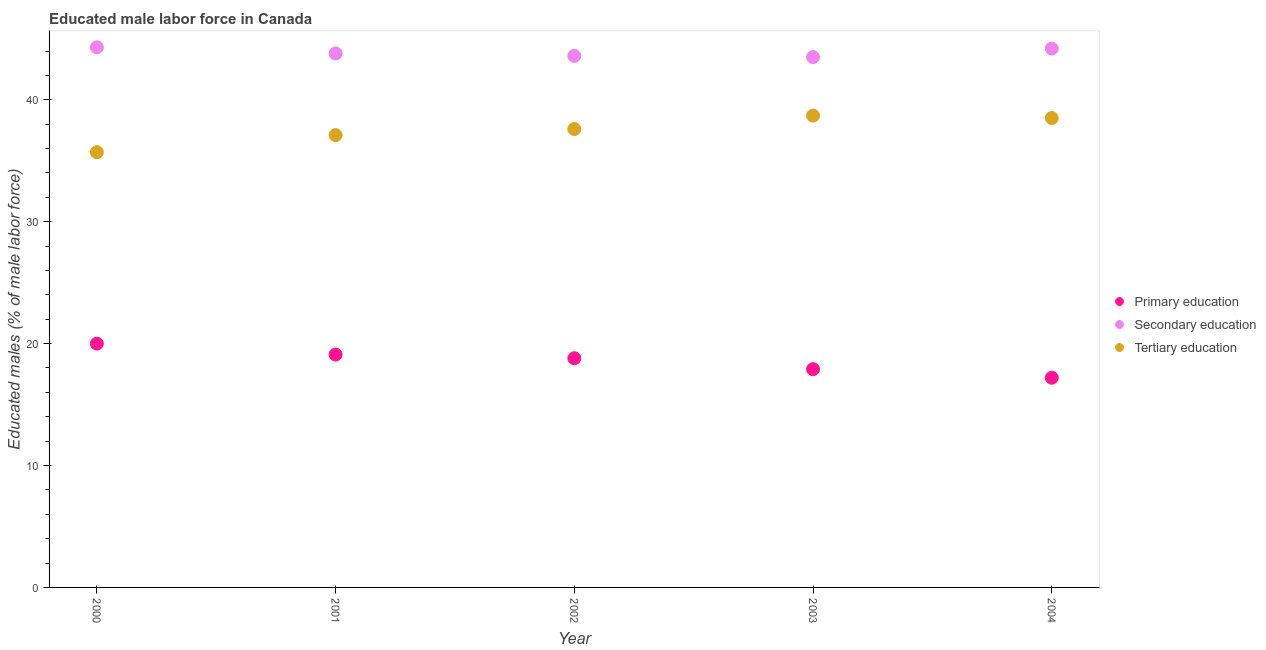How many different coloured dotlines are there?
Make the answer very short. 3. Is the number of dotlines equal to the number of legend labels?
Offer a very short reply. Yes. Across all years, what is the maximum percentage of male labor force who received tertiary education?
Offer a terse response. 38.7. Across all years, what is the minimum percentage of male labor force who received tertiary education?
Give a very brief answer. 35.7. In which year was the percentage of male labor force who received secondary education maximum?
Your answer should be compact. 2000. In which year was the percentage of male labor force who received tertiary education minimum?
Your response must be concise. 2000. What is the total percentage of male labor force who received tertiary education in the graph?
Make the answer very short. 187.6. What is the difference between the percentage of male labor force who received secondary education in 2001 and that in 2003?
Keep it short and to the point. 0.3. What is the difference between the percentage of male labor force who received secondary education in 2001 and the percentage of male labor force who received primary education in 2002?
Give a very brief answer. 25. What is the average percentage of male labor force who received primary education per year?
Offer a terse response. 18.6. In the year 2004, what is the difference between the percentage of male labor force who received tertiary education and percentage of male labor force who received secondary education?
Provide a succinct answer. -5.7. What is the ratio of the percentage of male labor force who received primary education in 2002 to that in 2004?
Offer a very short reply. 1.09. Is the percentage of male labor force who received secondary education in 2001 less than that in 2002?
Keep it short and to the point. No. Is the difference between the percentage of male labor force who received tertiary education in 2003 and 2004 greater than the difference between the percentage of male labor force who received primary education in 2003 and 2004?
Offer a very short reply. No. What is the difference between the highest and the second highest percentage of male labor force who received tertiary education?
Your answer should be compact. 0.2. What is the difference between the highest and the lowest percentage of male labor force who received secondary education?
Keep it short and to the point. 0.8. How many years are there in the graph?
Offer a terse response. 5. What is the difference between two consecutive major ticks on the Y-axis?
Ensure brevity in your answer.  10. Are the values on the major ticks of Y-axis written in scientific E-notation?
Your answer should be compact. No. How many legend labels are there?
Provide a short and direct response. 3. How are the legend labels stacked?
Your answer should be very brief. Vertical. What is the title of the graph?
Offer a terse response. Educated male labor force in Canada. What is the label or title of the X-axis?
Your response must be concise. Year. What is the label or title of the Y-axis?
Provide a short and direct response. Educated males (% of male labor force). What is the Educated males (% of male labor force) in Primary education in 2000?
Ensure brevity in your answer.  20. What is the Educated males (% of male labor force) in Secondary education in 2000?
Provide a short and direct response. 44.3. What is the Educated males (% of male labor force) of Tertiary education in 2000?
Offer a very short reply. 35.7. What is the Educated males (% of male labor force) in Primary education in 2001?
Your answer should be compact. 19.1. What is the Educated males (% of male labor force) in Secondary education in 2001?
Provide a short and direct response. 43.8. What is the Educated males (% of male labor force) of Tertiary education in 2001?
Provide a short and direct response. 37.1. What is the Educated males (% of male labor force) of Primary education in 2002?
Offer a very short reply. 18.8. What is the Educated males (% of male labor force) of Secondary education in 2002?
Give a very brief answer. 43.6. What is the Educated males (% of male labor force) in Tertiary education in 2002?
Your response must be concise. 37.6. What is the Educated males (% of male labor force) of Primary education in 2003?
Offer a terse response. 17.9. What is the Educated males (% of male labor force) of Secondary education in 2003?
Make the answer very short. 43.5. What is the Educated males (% of male labor force) of Tertiary education in 2003?
Make the answer very short. 38.7. What is the Educated males (% of male labor force) in Primary education in 2004?
Offer a very short reply. 17.2. What is the Educated males (% of male labor force) in Secondary education in 2004?
Provide a succinct answer. 44.2. What is the Educated males (% of male labor force) in Tertiary education in 2004?
Provide a succinct answer. 38.5. Across all years, what is the maximum Educated males (% of male labor force) of Secondary education?
Keep it short and to the point. 44.3. Across all years, what is the maximum Educated males (% of male labor force) of Tertiary education?
Your answer should be compact. 38.7. Across all years, what is the minimum Educated males (% of male labor force) of Primary education?
Offer a very short reply. 17.2. Across all years, what is the minimum Educated males (% of male labor force) in Secondary education?
Your answer should be compact. 43.5. Across all years, what is the minimum Educated males (% of male labor force) in Tertiary education?
Offer a terse response. 35.7. What is the total Educated males (% of male labor force) in Primary education in the graph?
Your answer should be compact. 93. What is the total Educated males (% of male labor force) in Secondary education in the graph?
Provide a short and direct response. 219.4. What is the total Educated males (% of male labor force) of Tertiary education in the graph?
Provide a short and direct response. 187.6. What is the difference between the Educated males (% of male labor force) of Primary education in 2000 and that in 2001?
Make the answer very short. 0.9. What is the difference between the Educated males (% of male labor force) of Secondary education in 2000 and that in 2001?
Provide a succinct answer. 0.5. What is the difference between the Educated males (% of male labor force) of Secondary education in 2000 and that in 2002?
Your response must be concise. 0.7. What is the difference between the Educated males (% of male labor force) of Tertiary education in 2000 and that in 2003?
Make the answer very short. -3. What is the difference between the Educated males (% of male labor force) in Secondary education in 2000 and that in 2004?
Offer a very short reply. 0.1. What is the difference between the Educated males (% of male labor force) in Primary education in 2001 and that in 2002?
Offer a very short reply. 0.3. What is the difference between the Educated males (% of male labor force) of Tertiary education in 2001 and that in 2002?
Ensure brevity in your answer.  -0.5. What is the difference between the Educated males (% of male labor force) in Secondary education in 2001 and that in 2003?
Give a very brief answer. 0.3. What is the difference between the Educated males (% of male labor force) in Primary education in 2001 and that in 2004?
Your answer should be compact. 1.9. What is the difference between the Educated males (% of male labor force) of Tertiary education in 2001 and that in 2004?
Give a very brief answer. -1.4. What is the difference between the Educated males (% of male labor force) in Secondary education in 2002 and that in 2003?
Provide a succinct answer. 0.1. What is the difference between the Educated males (% of male labor force) of Primary education in 2002 and that in 2004?
Your response must be concise. 1.6. What is the difference between the Educated males (% of male labor force) in Primary education in 2000 and the Educated males (% of male labor force) in Secondary education in 2001?
Keep it short and to the point. -23.8. What is the difference between the Educated males (% of male labor force) of Primary education in 2000 and the Educated males (% of male labor force) of Tertiary education in 2001?
Your answer should be compact. -17.1. What is the difference between the Educated males (% of male labor force) of Secondary education in 2000 and the Educated males (% of male labor force) of Tertiary education in 2001?
Offer a terse response. 7.2. What is the difference between the Educated males (% of male labor force) in Primary education in 2000 and the Educated males (% of male labor force) in Secondary education in 2002?
Your answer should be compact. -23.6. What is the difference between the Educated males (% of male labor force) in Primary education in 2000 and the Educated males (% of male labor force) in Tertiary education in 2002?
Give a very brief answer. -17.6. What is the difference between the Educated males (% of male labor force) in Secondary education in 2000 and the Educated males (% of male labor force) in Tertiary education in 2002?
Offer a terse response. 6.7. What is the difference between the Educated males (% of male labor force) in Primary education in 2000 and the Educated males (% of male labor force) in Secondary education in 2003?
Give a very brief answer. -23.5. What is the difference between the Educated males (% of male labor force) of Primary education in 2000 and the Educated males (% of male labor force) of Tertiary education in 2003?
Provide a succinct answer. -18.7. What is the difference between the Educated males (% of male labor force) of Secondary education in 2000 and the Educated males (% of male labor force) of Tertiary education in 2003?
Offer a terse response. 5.6. What is the difference between the Educated males (% of male labor force) of Primary education in 2000 and the Educated males (% of male labor force) of Secondary education in 2004?
Ensure brevity in your answer.  -24.2. What is the difference between the Educated males (% of male labor force) in Primary education in 2000 and the Educated males (% of male labor force) in Tertiary education in 2004?
Your answer should be very brief. -18.5. What is the difference between the Educated males (% of male labor force) of Primary education in 2001 and the Educated males (% of male labor force) of Secondary education in 2002?
Keep it short and to the point. -24.5. What is the difference between the Educated males (% of male labor force) of Primary education in 2001 and the Educated males (% of male labor force) of Tertiary education in 2002?
Ensure brevity in your answer.  -18.5. What is the difference between the Educated males (% of male labor force) in Secondary education in 2001 and the Educated males (% of male labor force) in Tertiary education in 2002?
Give a very brief answer. 6.2. What is the difference between the Educated males (% of male labor force) of Primary education in 2001 and the Educated males (% of male labor force) of Secondary education in 2003?
Ensure brevity in your answer.  -24.4. What is the difference between the Educated males (% of male labor force) of Primary education in 2001 and the Educated males (% of male labor force) of Tertiary education in 2003?
Your response must be concise. -19.6. What is the difference between the Educated males (% of male labor force) in Secondary education in 2001 and the Educated males (% of male labor force) in Tertiary education in 2003?
Keep it short and to the point. 5.1. What is the difference between the Educated males (% of male labor force) of Primary education in 2001 and the Educated males (% of male labor force) of Secondary education in 2004?
Your response must be concise. -25.1. What is the difference between the Educated males (% of male labor force) of Primary education in 2001 and the Educated males (% of male labor force) of Tertiary education in 2004?
Give a very brief answer. -19.4. What is the difference between the Educated males (% of male labor force) of Primary education in 2002 and the Educated males (% of male labor force) of Secondary education in 2003?
Keep it short and to the point. -24.7. What is the difference between the Educated males (% of male labor force) of Primary education in 2002 and the Educated males (% of male labor force) of Tertiary education in 2003?
Provide a short and direct response. -19.9. What is the difference between the Educated males (% of male labor force) of Primary education in 2002 and the Educated males (% of male labor force) of Secondary education in 2004?
Ensure brevity in your answer.  -25.4. What is the difference between the Educated males (% of male labor force) in Primary education in 2002 and the Educated males (% of male labor force) in Tertiary education in 2004?
Offer a very short reply. -19.7. What is the difference between the Educated males (% of male labor force) in Secondary education in 2002 and the Educated males (% of male labor force) in Tertiary education in 2004?
Give a very brief answer. 5.1. What is the difference between the Educated males (% of male labor force) in Primary education in 2003 and the Educated males (% of male labor force) in Secondary education in 2004?
Provide a succinct answer. -26.3. What is the difference between the Educated males (% of male labor force) in Primary education in 2003 and the Educated males (% of male labor force) in Tertiary education in 2004?
Offer a terse response. -20.6. What is the difference between the Educated males (% of male labor force) of Secondary education in 2003 and the Educated males (% of male labor force) of Tertiary education in 2004?
Keep it short and to the point. 5. What is the average Educated males (% of male labor force) of Primary education per year?
Provide a short and direct response. 18.6. What is the average Educated males (% of male labor force) of Secondary education per year?
Keep it short and to the point. 43.88. What is the average Educated males (% of male labor force) in Tertiary education per year?
Your answer should be compact. 37.52. In the year 2000, what is the difference between the Educated males (% of male labor force) of Primary education and Educated males (% of male labor force) of Secondary education?
Ensure brevity in your answer.  -24.3. In the year 2000, what is the difference between the Educated males (% of male labor force) in Primary education and Educated males (% of male labor force) in Tertiary education?
Offer a terse response. -15.7. In the year 2000, what is the difference between the Educated males (% of male labor force) in Secondary education and Educated males (% of male labor force) in Tertiary education?
Ensure brevity in your answer.  8.6. In the year 2001, what is the difference between the Educated males (% of male labor force) in Primary education and Educated males (% of male labor force) in Secondary education?
Ensure brevity in your answer.  -24.7. In the year 2001, what is the difference between the Educated males (% of male labor force) in Primary education and Educated males (% of male labor force) in Tertiary education?
Offer a terse response. -18. In the year 2002, what is the difference between the Educated males (% of male labor force) in Primary education and Educated males (% of male labor force) in Secondary education?
Your response must be concise. -24.8. In the year 2002, what is the difference between the Educated males (% of male labor force) of Primary education and Educated males (% of male labor force) of Tertiary education?
Provide a short and direct response. -18.8. In the year 2003, what is the difference between the Educated males (% of male labor force) of Primary education and Educated males (% of male labor force) of Secondary education?
Your answer should be very brief. -25.6. In the year 2003, what is the difference between the Educated males (% of male labor force) of Primary education and Educated males (% of male labor force) of Tertiary education?
Your answer should be very brief. -20.8. In the year 2004, what is the difference between the Educated males (% of male labor force) of Primary education and Educated males (% of male labor force) of Tertiary education?
Offer a terse response. -21.3. In the year 2004, what is the difference between the Educated males (% of male labor force) in Secondary education and Educated males (% of male labor force) in Tertiary education?
Give a very brief answer. 5.7. What is the ratio of the Educated males (% of male labor force) in Primary education in 2000 to that in 2001?
Ensure brevity in your answer.  1.05. What is the ratio of the Educated males (% of male labor force) of Secondary education in 2000 to that in 2001?
Provide a succinct answer. 1.01. What is the ratio of the Educated males (% of male labor force) in Tertiary education in 2000 to that in 2001?
Give a very brief answer. 0.96. What is the ratio of the Educated males (% of male labor force) of Primary education in 2000 to that in 2002?
Provide a succinct answer. 1.06. What is the ratio of the Educated males (% of male labor force) of Secondary education in 2000 to that in 2002?
Your answer should be very brief. 1.02. What is the ratio of the Educated males (% of male labor force) in Tertiary education in 2000 to that in 2002?
Your answer should be compact. 0.95. What is the ratio of the Educated males (% of male labor force) of Primary education in 2000 to that in 2003?
Ensure brevity in your answer.  1.12. What is the ratio of the Educated males (% of male labor force) of Secondary education in 2000 to that in 2003?
Ensure brevity in your answer.  1.02. What is the ratio of the Educated males (% of male labor force) of Tertiary education in 2000 to that in 2003?
Provide a succinct answer. 0.92. What is the ratio of the Educated males (% of male labor force) in Primary education in 2000 to that in 2004?
Offer a very short reply. 1.16. What is the ratio of the Educated males (% of male labor force) of Secondary education in 2000 to that in 2004?
Your answer should be compact. 1. What is the ratio of the Educated males (% of male labor force) of Tertiary education in 2000 to that in 2004?
Offer a terse response. 0.93. What is the ratio of the Educated males (% of male labor force) in Primary education in 2001 to that in 2002?
Ensure brevity in your answer.  1.02. What is the ratio of the Educated males (% of male labor force) in Tertiary education in 2001 to that in 2002?
Your answer should be very brief. 0.99. What is the ratio of the Educated males (% of male labor force) in Primary education in 2001 to that in 2003?
Provide a succinct answer. 1.07. What is the ratio of the Educated males (% of male labor force) in Tertiary education in 2001 to that in 2003?
Provide a succinct answer. 0.96. What is the ratio of the Educated males (% of male labor force) in Primary education in 2001 to that in 2004?
Ensure brevity in your answer.  1.11. What is the ratio of the Educated males (% of male labor force) of Secondary education in 2001 to that in 2004?
Keep it short and to the point. 0.99. What is the ratio of the Educated males (% of male labor force) in Tertiary education in 2001 to that in 2004?
Your response must be concise. 0.96. What is the ratio of the Educated males (% of male labor force) in Primary education in 2002 to that in 2003?
Your answer should be very brief. 1.05. What is the ratio of the Educated males (% of male labor force) of Secondary education in 2002 to that in 2003?
Your answer should be very brief. 1. What is the ratio of the Educated males (% of male labor force) in Tertiary education in 2002 to that in 2003?
Give a very brief answer. 0.97. What is the ratio of the Educated males (% of male labor force) of Primary education in 2002 to that in 2004?
Make the answer very short. 1.09. What is the ratio of the Educated males (% of male labor force) of Secondary education in 2002 to that in 2004?
Offer a terse response. 0.99. What is the ratio of the Educated males (% of male labor force) of Tertiary education in 2002 to that in 2004?
Give a very brief answer. 0.98. What is the ratio of the Educated males (% of male labor force) of Primary education in 2003 to that in 2004?
Provide a succinct answer. 1.04. What is the ratio of the Educated males (% of male labor force) of Secondary education in 2003 to that in 2004?
Your answer should be very brief. 0.98. What is the ratio of the Educated males (% of male labor force) of Tertiary education in 2003 to that in 2004?
Your answer should be compact. 1.01. What is the difference between the highest and the second highest Educated males (% of male labor force) in Primary education?
Your answer should be very brief. 0.9. What is the difference between the highest and the second highest Educated males (% of male labor force) in Tertiary education?
Your answer should be compact. 0.2. What is the difference between the highest and the lowest Educated males (% of male labor force) in Secondary education?
Your answer should be very brief. 0.8. What is the difference between the highest and the lowest Educated males (% of male labor force) of Tertiary education?
Offer a terse response. 3. 